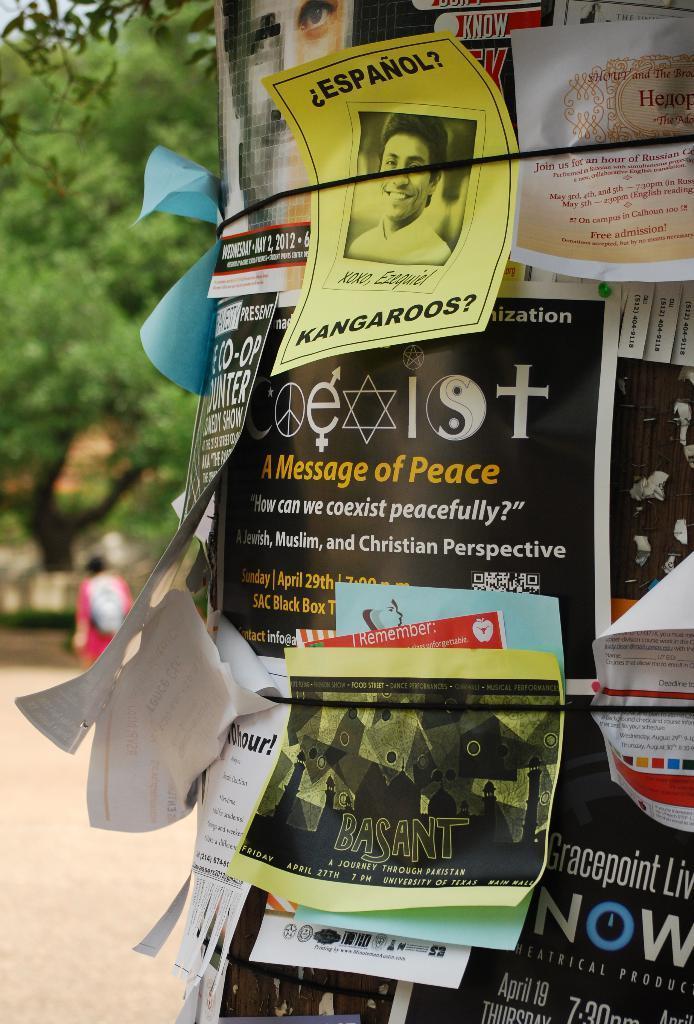How would you summarize this image in a sentence or two? This picture is clicked outside. On the right we can see the text and some pictures on the papers and we can see the text and numbers on the posters attached to the item. In the background we can see the trees, a person and the ground and some other objects. 